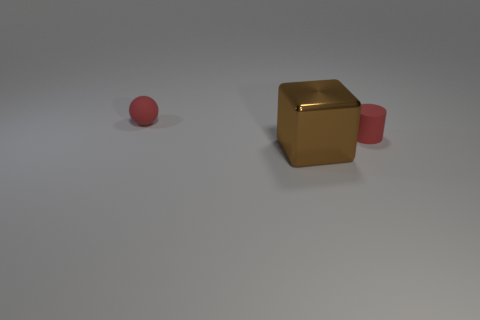There is a small ball that is the same color as the cylinder; what material is it?
Offer a very short reply. Rubber. What number of other things are the same color as the big metal cube?
Your answer should be very brief. 0. Are there more rubber things than brown shiny cubes?
Your answer should be compact. Yes. There is a sphere; does it have the same size as the brown block that is to the right of the tiny matte ball?
Make the answer very short. No. There is a tiny rubber object that is to the right of the brown shiny block; what is its color?
Your response must be concise. Red. How many red objects are rubber objects or large things?
Make the answer very short. 2. What is the color of the cylinder?
Provide a succinct answer. Red. Is there anything else that is made of the same material as the block?
Ensure brevity in your answer.  No. Are there fewer red cylinders that are in front of the ball than small red cylinders in front of the large block?
Make the answer very short. No. What shape is the object that is both on the left side of the red rubber cylinder and behind the large cube?
Ensure brevity in your answer.  Sphere. 